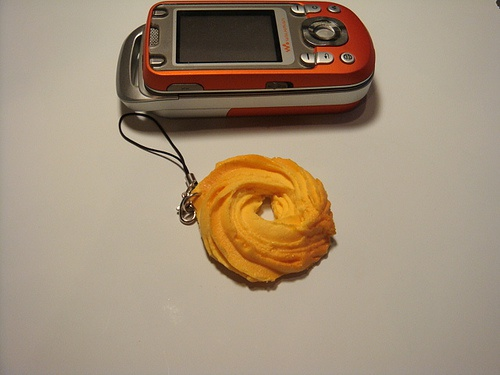Describe the objects in this image and their specific colors. I can see a cell phone in gray, black, and maroon tones in this image. 